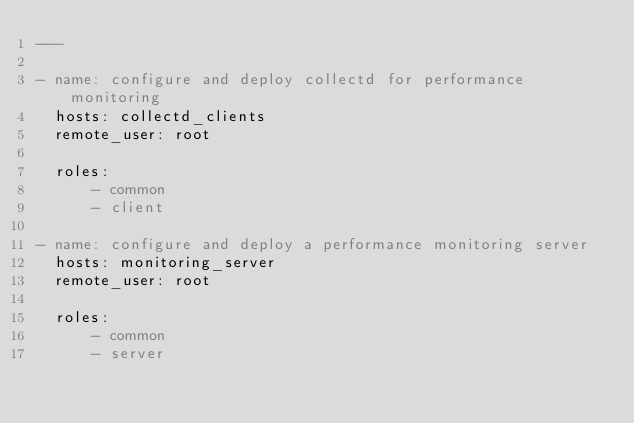Convert code to text. <code><loc_0><loc_0><loc_500><loc_500><_YAML_>---

- name: configure and deploy collectd for performance monitoring
  hosts: collectd_clients
  remote_user: root

  roles:
      - common
      - client

- name: configure and deploy a performance monitoring server
  hosts: monitoring_server
  remote_user: root

  roles:
      - common
      - server
</code> 